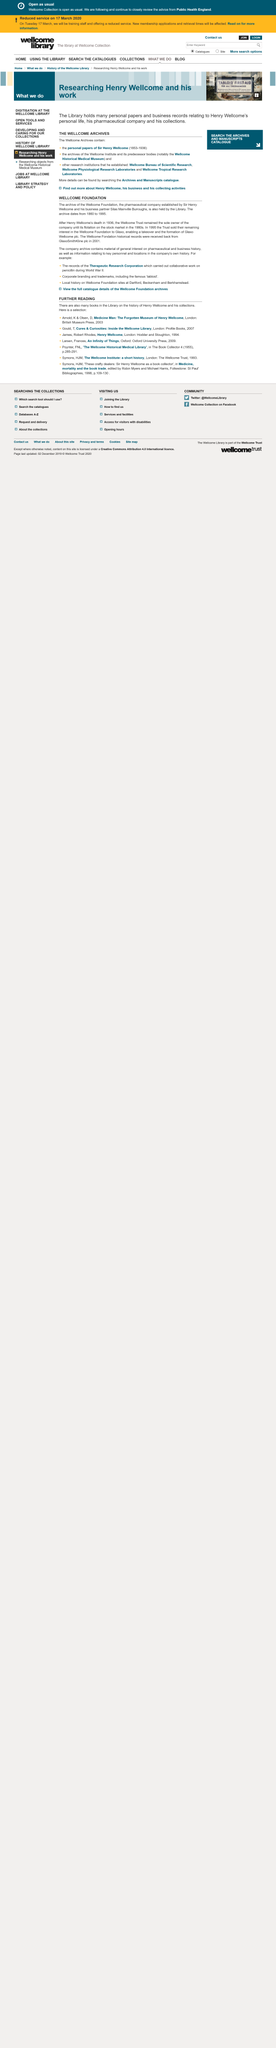Highlight a few significant elements in this photo. In 1936, Henry Wellcome passed away. The Wellcome Foundation's archive dates from 1860 to 1995. The Wellcome Foundation is a pharmaceutical company. 